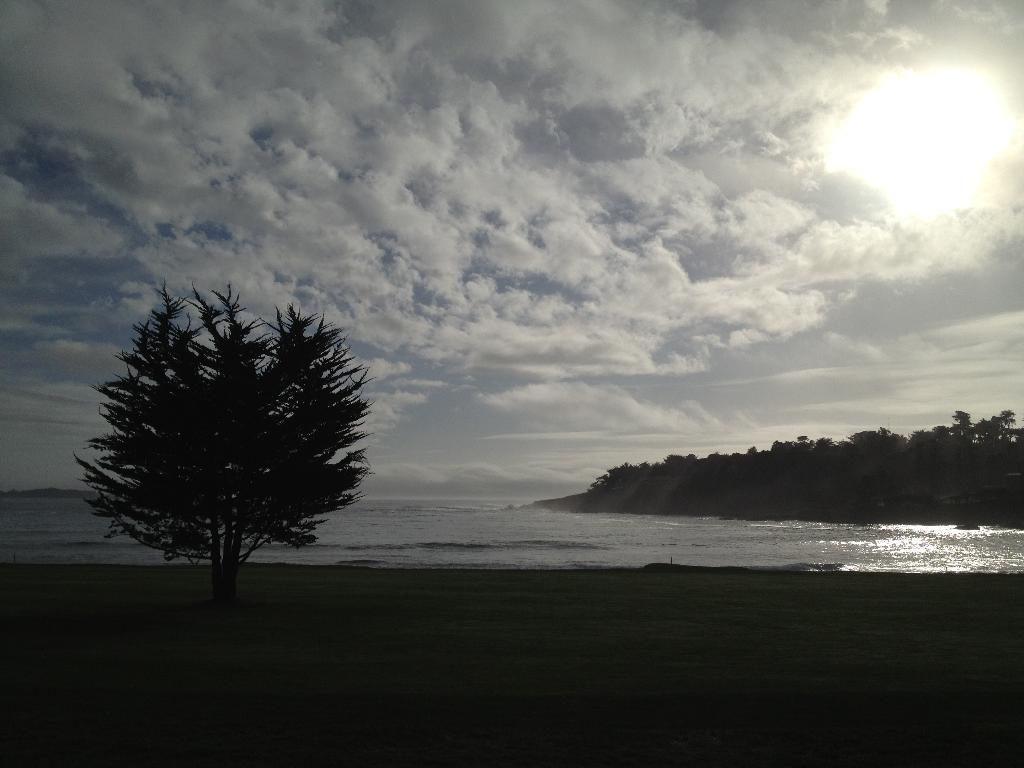What type of vegetation can be seen in the image? There are trees in the image. What natural element is visible in the image besides trees? There is water visible in the image. How would you describe the sky in the image? The sky is cloudy in the image. Can you see any celestial bodies in the image? Yes, the sun is visible in the image. What is the ground covered with in the image? There is grass on the ground in the image. What type of voice can be heard coming from the trees in the image? There is no voice present in the image; it only features trees, water, a cloudy sky, the sun, and grass. Is there a whip visible in the image? No, there is no whip present in the image. 